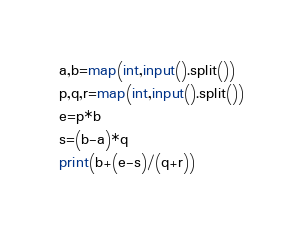Convert code to text. <code><loc_0><loc_0><loc_500><loc_500><_Python_>a,b=map(int,input().split())
p,q,r=map(int,input().split())
e=p*b
s=(b-a)*q
print(b+(e-s)/(q+r))
</code> 